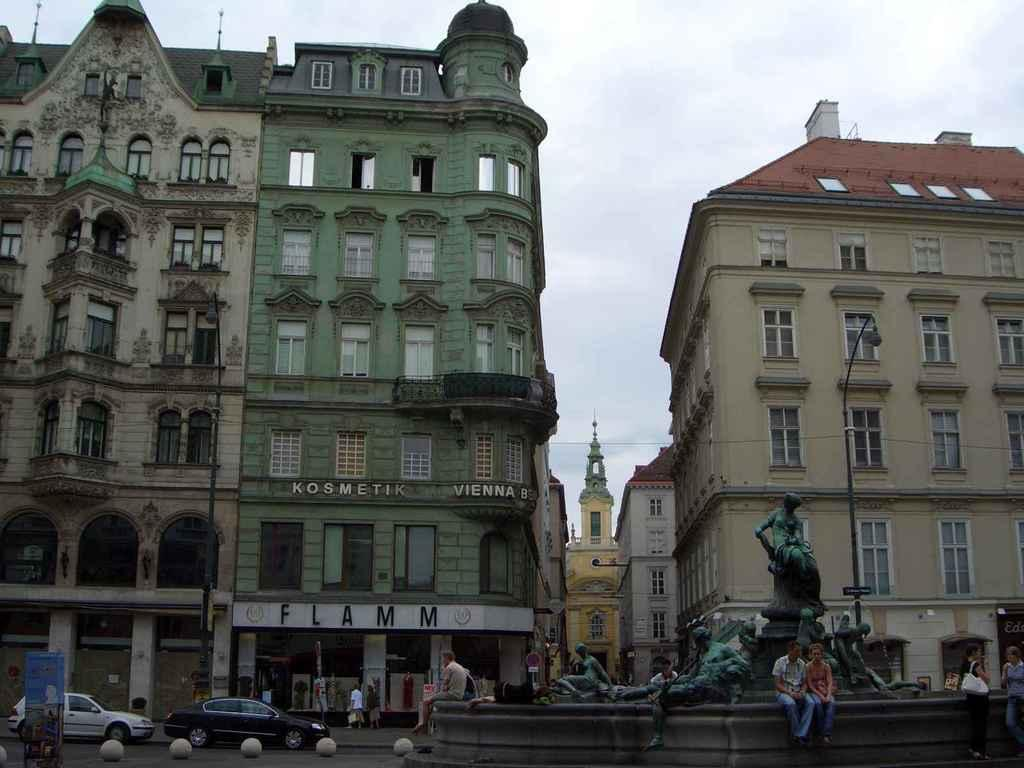<image>
Describe the image concisely. A store front of Flamm boutique at the first floor of a green colored building. 